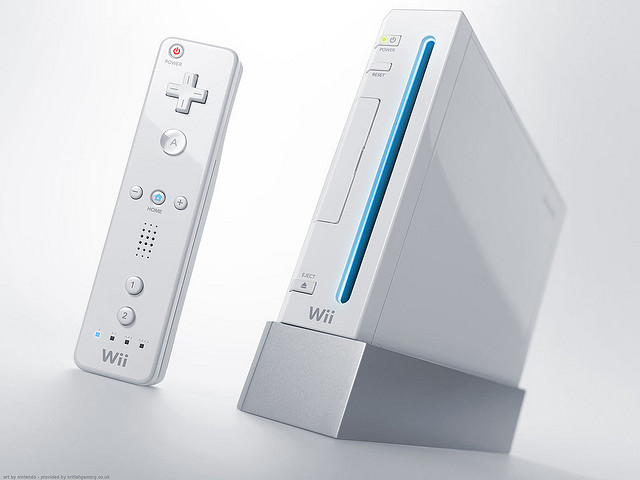Read all the text in this image. Wii Wii A 